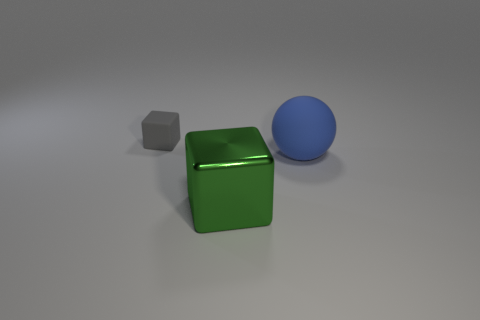Is there any other thing that has the same size as the gray matte object?
Provide a short and direct response. No. What number of tiny cubes are there?
Offer a very short reply. 1. Does the tiny gray cube have the same material as the thing on the right side of the green shiny block?
Your answer should be very brief. Yes. There is a matte object that is behind the big matte thing; does it have the same color as the shiny cube?
Offer a very short reply. No. There is a object that is both to the right of the gray rubber thing and to the left of the matte sphere; what is its material?
Give a very brief answer. Metal. The gray object is what size?
Provide a short and direct response. Small. What number of other things are there of the same color as the large metallic thing?
Offer a very short reply. 0. Do the object that is right of the big metal block and the object that is in front of the blue matte ball have the same size?
Keep it short and to the point. Yes. There is a large thing that is on the left side of the blue ball; what color is it?
Your response must be concise. Green. Is the number of large rubber spheres that are on the left side of the blue object less than the number of small yellow cubes?
Make the answer very short. No. 